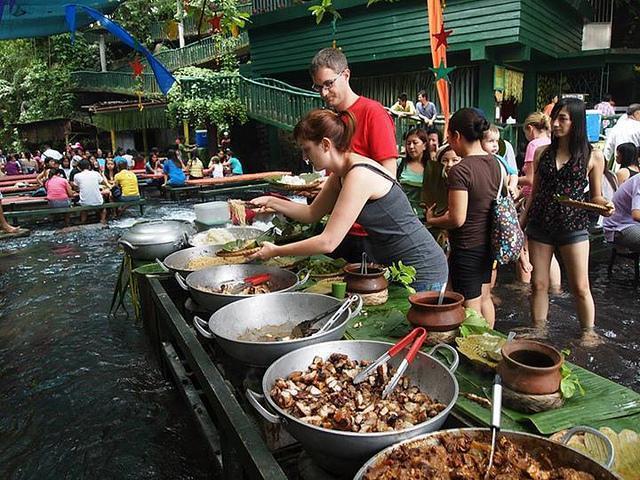How many people are in the photo?
Give a very brief answer. 5. How many bowls can be seen?
Give a very brief answer. 3. How many dining tables can you see?
Give a very brief answer. 2. How many cats are on the umbrella?
Give a very brief answer. 0. 